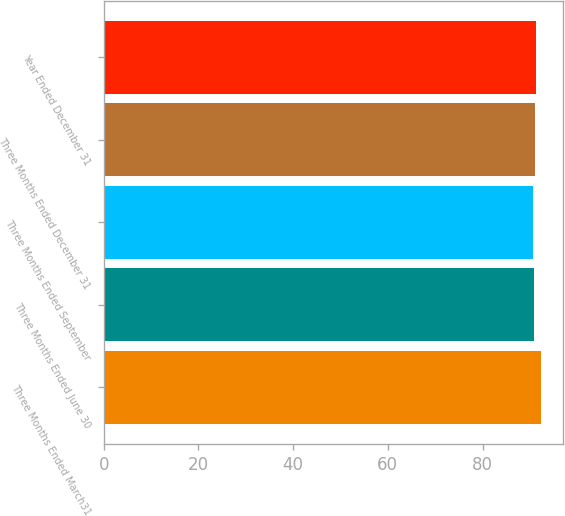Convert chart to OTSL. <chart><loc_0><loc_0><loc_500><loc_500><bar_chart><fcel>Three Months Ended March31<fcel>Three Months Ended June 30<fcel>Three Months Ended September<fcel>Three Months Ended December 31<fcel>Year Ended December 31<nl><fcel>92.4<fcel>90.87<fcel>90.7<fcel>91.1<fcel>91.27<nl></chart> 